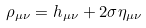Convert formula to latex. <formula><loc_0><loc_0><loc_500><loc_500>\rho _ { \mu \nu } = h _ { \mu \nu } + 2 \sigma \eta _ { \mu \nu }</formula> 